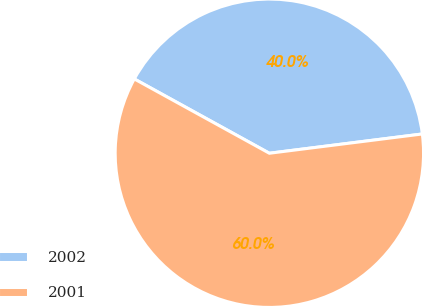<chart> <loc_0><loc_0><loc_500><loc_500><pie_chart><fcel>2002<fcel>2001<nl><fcel>40.0%<fcel>60.0%<nl></chart> 